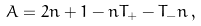Convert formula to latex. <formula><loc_0><loc_0><loc_500><loc_500>A = 2 n + 1 - n T _ { + } - T _ { - } n \, ,</formula> 